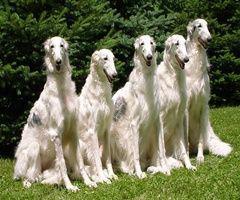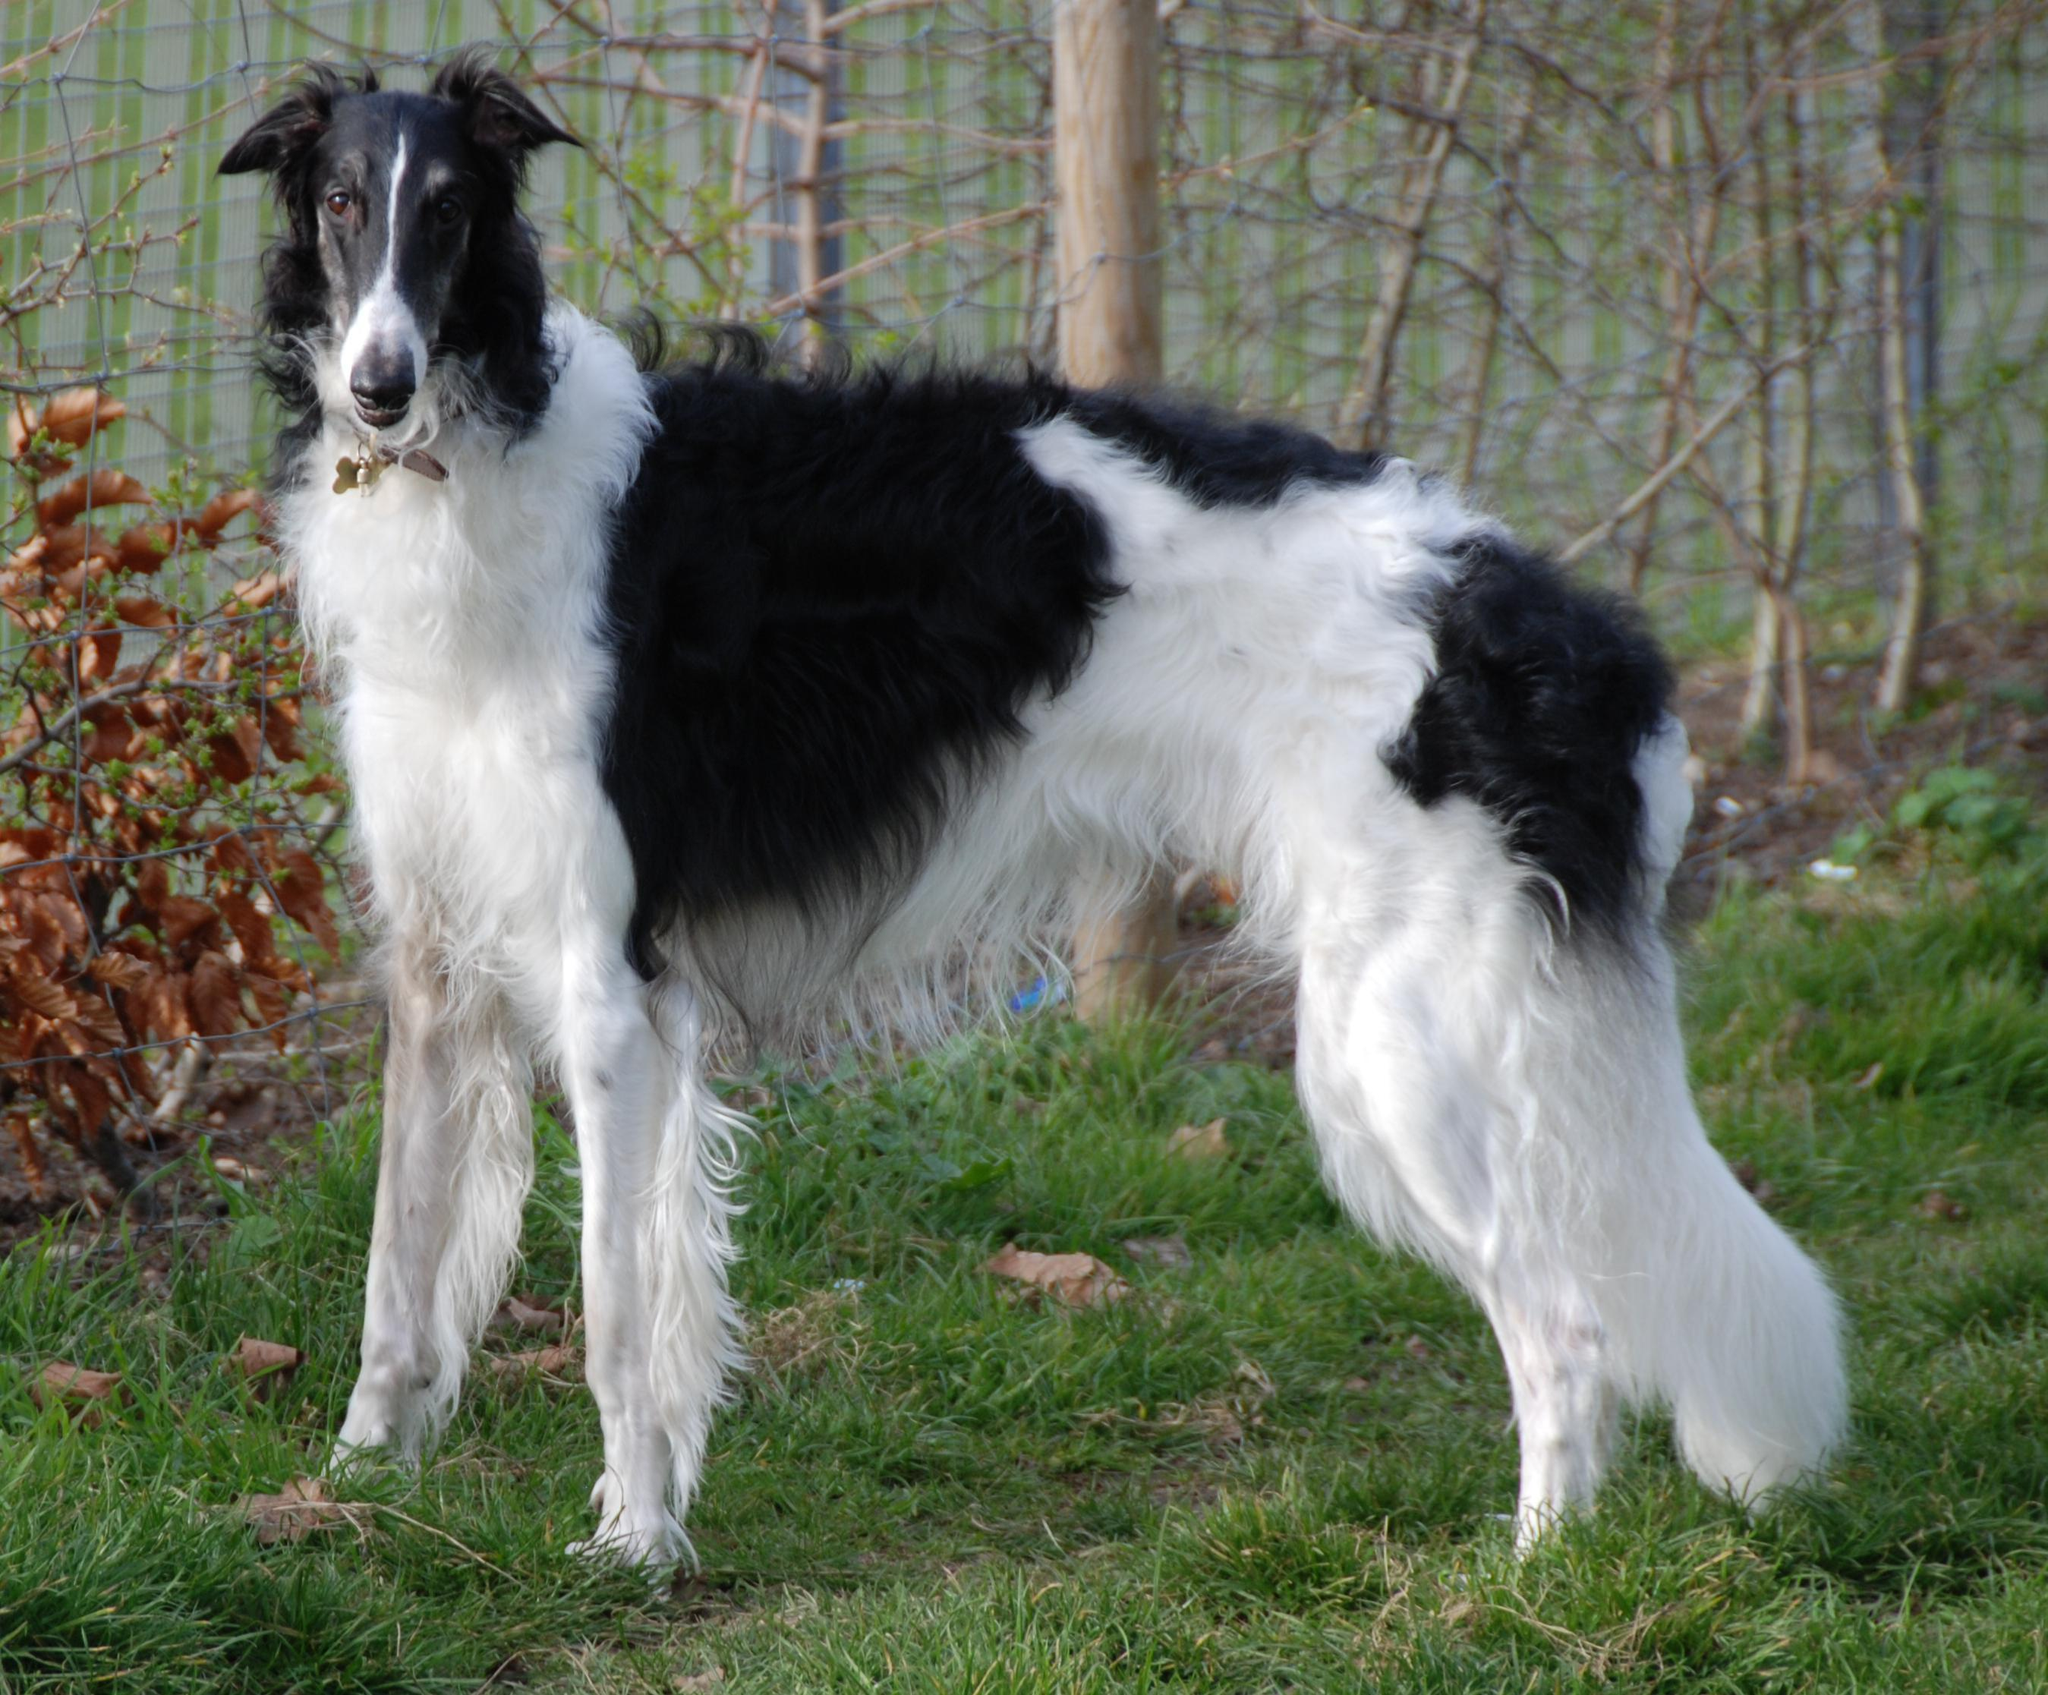The first image is the image on the left, the second image is the image on the right. For the images displayed, is the sentence "An image shows exactly two pet hounds on grass." factually correct? Answer yes or no. No. The first image is the image on the left, the second image is the image on the right. Examine the images to the left and right. Is the description "One image shows a single dog standing in grass." accurate? Answer yes or no. Yes. 